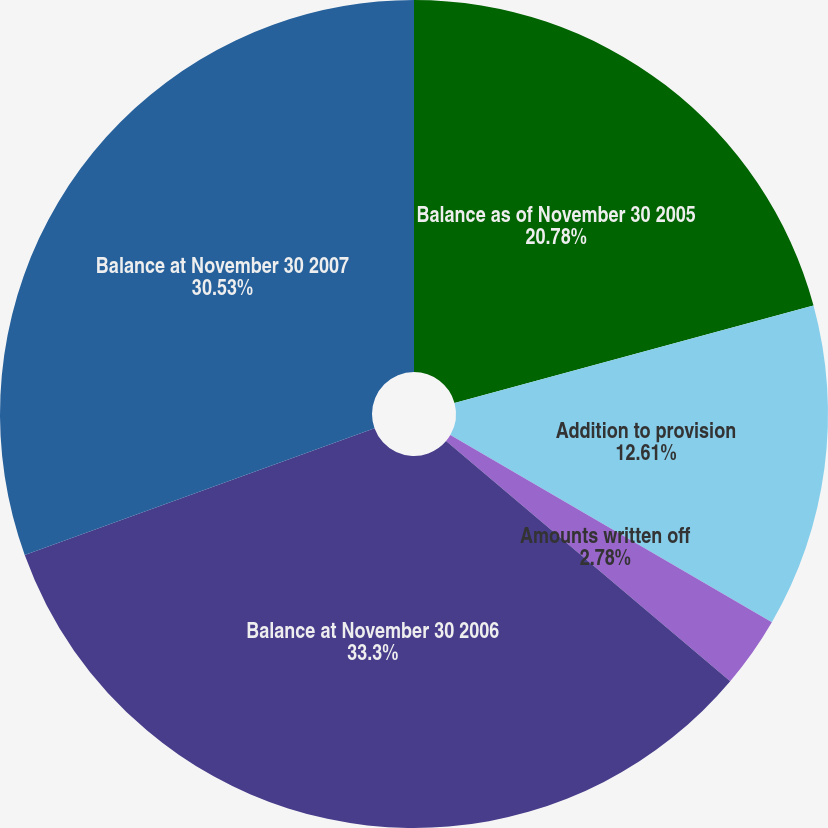Convert chart. <chart><loc_0><loc_0><loc_500><loc_500><pie_chart><fcel>Balance as of November 30 2005<fcel>Addition to provision<fcel>Amounts written off<fcel>Balance at November 30 2006<fcel>Balance at November 30 2007<nl><fcel>20.78%<fcel>12.61%<fcel>2.78%<fcel>33.31%<fcel>30.53%<nl></chart> 